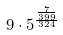<formula> <loc_0><loc_0><loc_500><loc_500>9 \cdot 5 ^ { \frac { \frac { 7 } { 3 9 9 } } { 3 2 4 } }</formula> 